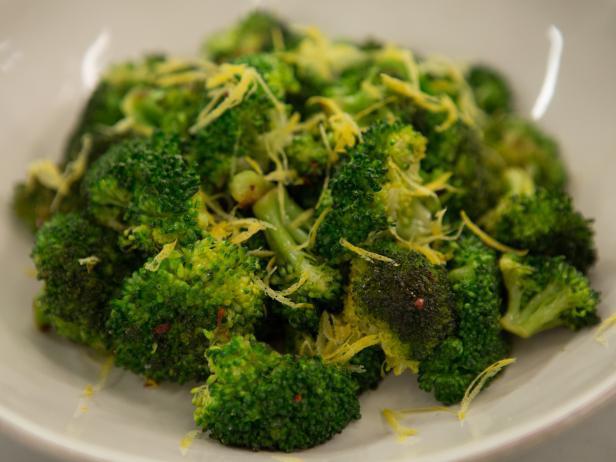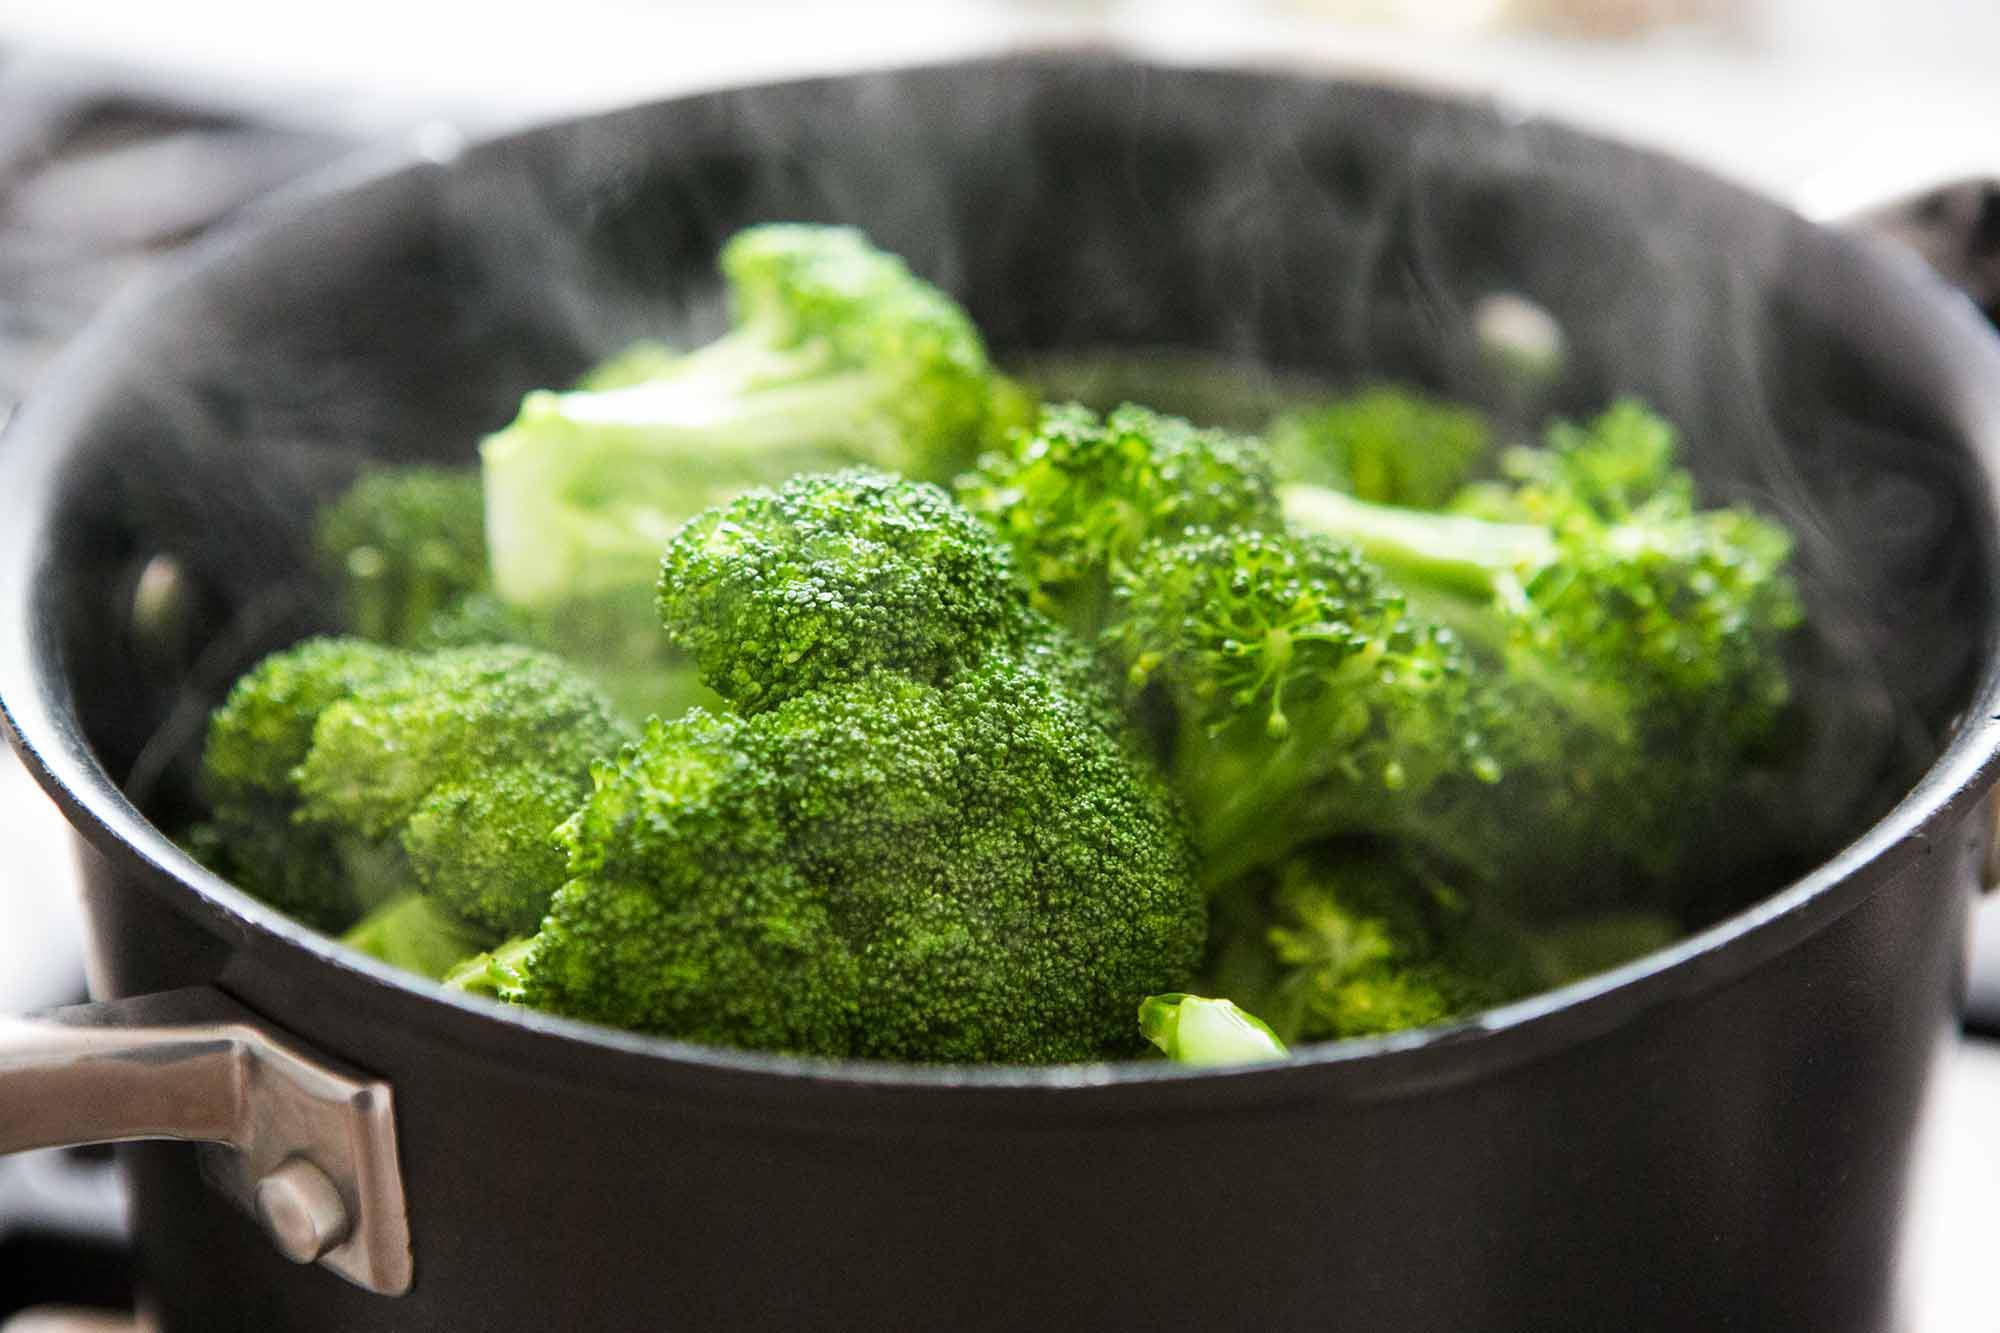The first image is the image on the left, the second image is the image on the right. For the images displayed, is the sentence "One photo features a container made of metal." factually correct? Answer yes or no. Yes. The first image is the image on the left, the second image is the image on the right. For the images shown, is this caption "Right image shows broccoli in a deep container with water." true? Answer yes or no. Yes. 